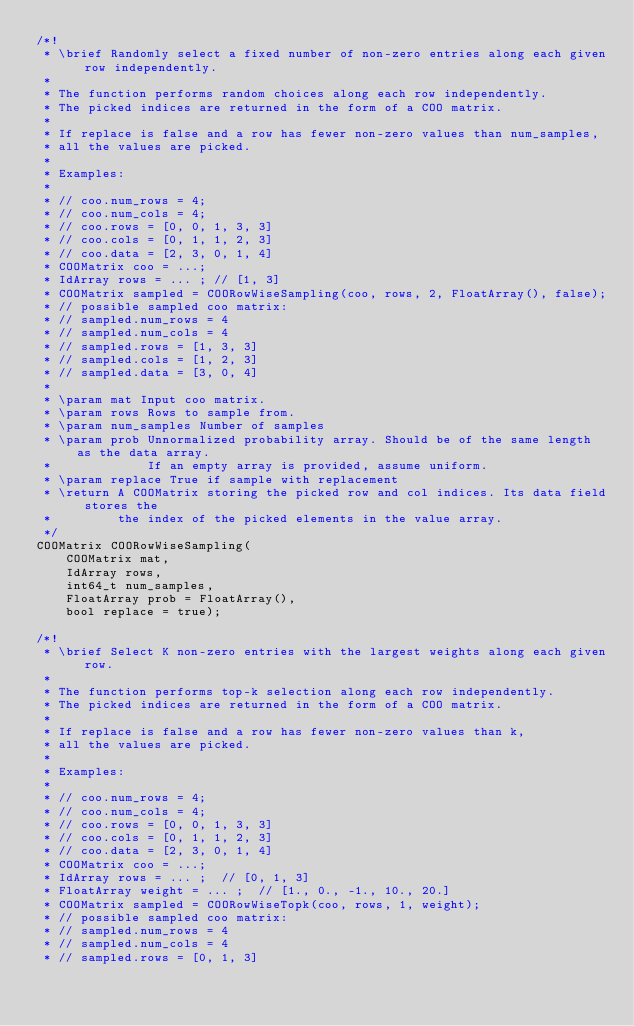Convert code to text. <code><loc_0><loc_0><loc_500><loc_500><_C_>/*!
 * \brief Randomly select a fixed number of non-zero entries along each given row independently.
 *
 * The function performs random choices along each row independently.
 * The picked indices are returned in the form of a COO matrix.
 *
 * If replace is false and a row has fewer non-zero values than num_samples,
 * all the values are picked.
 *
 * Examples:
 *
 * // coo.num_rows = 4;
 * // coo.num_cols = 4;
 * // coo.rows = [0, 0, 1, 3, 3]
 * // coo.cols = [0, 1, 1, 2, 3]
 * // coo.data = [2, 3, 0, 1, 4]
 * COOMatrix coo = ...;
 * IdArray rows = ... ; // [1, 3]
 * COOMatrix sampled = COORowWiseSampling(coo, rows, 2, FloatArray(), false);
 * // possible sampled coo matrix:
 * // sampled.num_rows = 4
 * // sampled.num_cols = 4
 * // sampled.rows = [1, 3, 3]
 * // sampled.cols = [1, 2, 3]
 * // sampled.data = [3, 0, 4]
 *
 * \param mat Input coo matrix.
 * \param rows Rows to sample from.
 * \param num_samples Number of samples
 * \param prob Unnormalized probability array. Should be of the same length as the data array.
 *             If an empty array is provided, assume uniform.
 * \param replace True if sample with replacement
 * \return A COOMatrix storing the picked row and col indices. Its data field stores the
 *         the index of the picked elements in the value array.
 */
COOMatrix COORowWiseSampling(
    COOMatrix mat,
    IdArray rows,
    int64_t num_samples,
    FloatArray prob = FloatArray(),
    bool replace = true);

/*!
 * \brief Select K non-zero entries with the largest weights along each given row.
 *
 * The function performs top-k selection along each row independently.
 * The picked indices are returned in the form of a COO matrix.
 *
 * If replace is false and a row has fewer non-zero values than k,
 * all the values are picked.
 *
 * Examples:
 *
 * // coo.num_rows = 4;
 * // coo.num_cols = 4;
 * // coo.rows = [0, 0, 1, 3, 3]
 * // coo.cols = [0, 1, 1, 2, 3]
 * // coo.data = [2, 3, 0, 1, 4]
 * COOMatrix coo = ...;
 * IdArray rows = ... ;  // [0, 1, 3]
 * FloatArray weight = ... ;  // [1., 0., -1., 10., 20.]
 * COOMatrix sampled = COORowWiseTopk(coo, rows, 1, weight);
 * // possible sampled coo matrix:
 * // sampled.num_rows = 4
 * // sampled.num_cols = 4
 * // sampled.rows = [0, 1, 3]</code> 